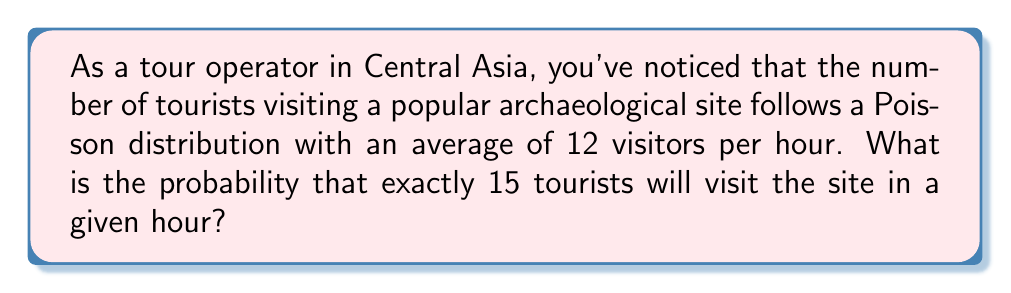Could you help me with this problem? To solve this problem, we'll use the Poisson probability mass function. The Poisson distribution is often used to model the number of events occurring in a fixed interval of time when these events happen with a known average rate.

The Poisson probability mass function is given by:

$$P(X = k) = \frac{e^{-\lambda} \lambda^k}{k!}$$

Where:
- $\lambda$ is the average number of events per interval
- $k$ is the number of events we're interested in
- $e$ is Euler's number (approximately 2.71828)

In this case:
- $\lambda = 12$ (average of 12 visitors per hour)
- $k = 15$ (we're interested in exactly 15 visitors)

Let's substitute these values into the formula:

$$P(X = 15) = \frac{e^{-12} 12^{15}}{15!}$$

Now, let's calculate this step-by-step:

1) First, calculate $e^{-12}$:
   $e^{-12} \approx 6.14421 \times 10^{-6}$

2) Next, calculate $12^{15}$:
   $12^{15} = 1.29746 \times 10^{16}$

3) Calculate 15!:
   $15! = 1,307,674,368,000$

4) Now, put it all together:

   $$\frac{(6.14421 \times 10^{-6})(1.29746 \times 10^{16})}{1,307,674,368,000}$$

5) Simplify:
   $\approx 0.0608$

Therefore, the probability of exactly 15 tourists visiting the site in a given hour is approximately 0.0608 or 6.08%.
Answer: 0.0608 or 6.08% 